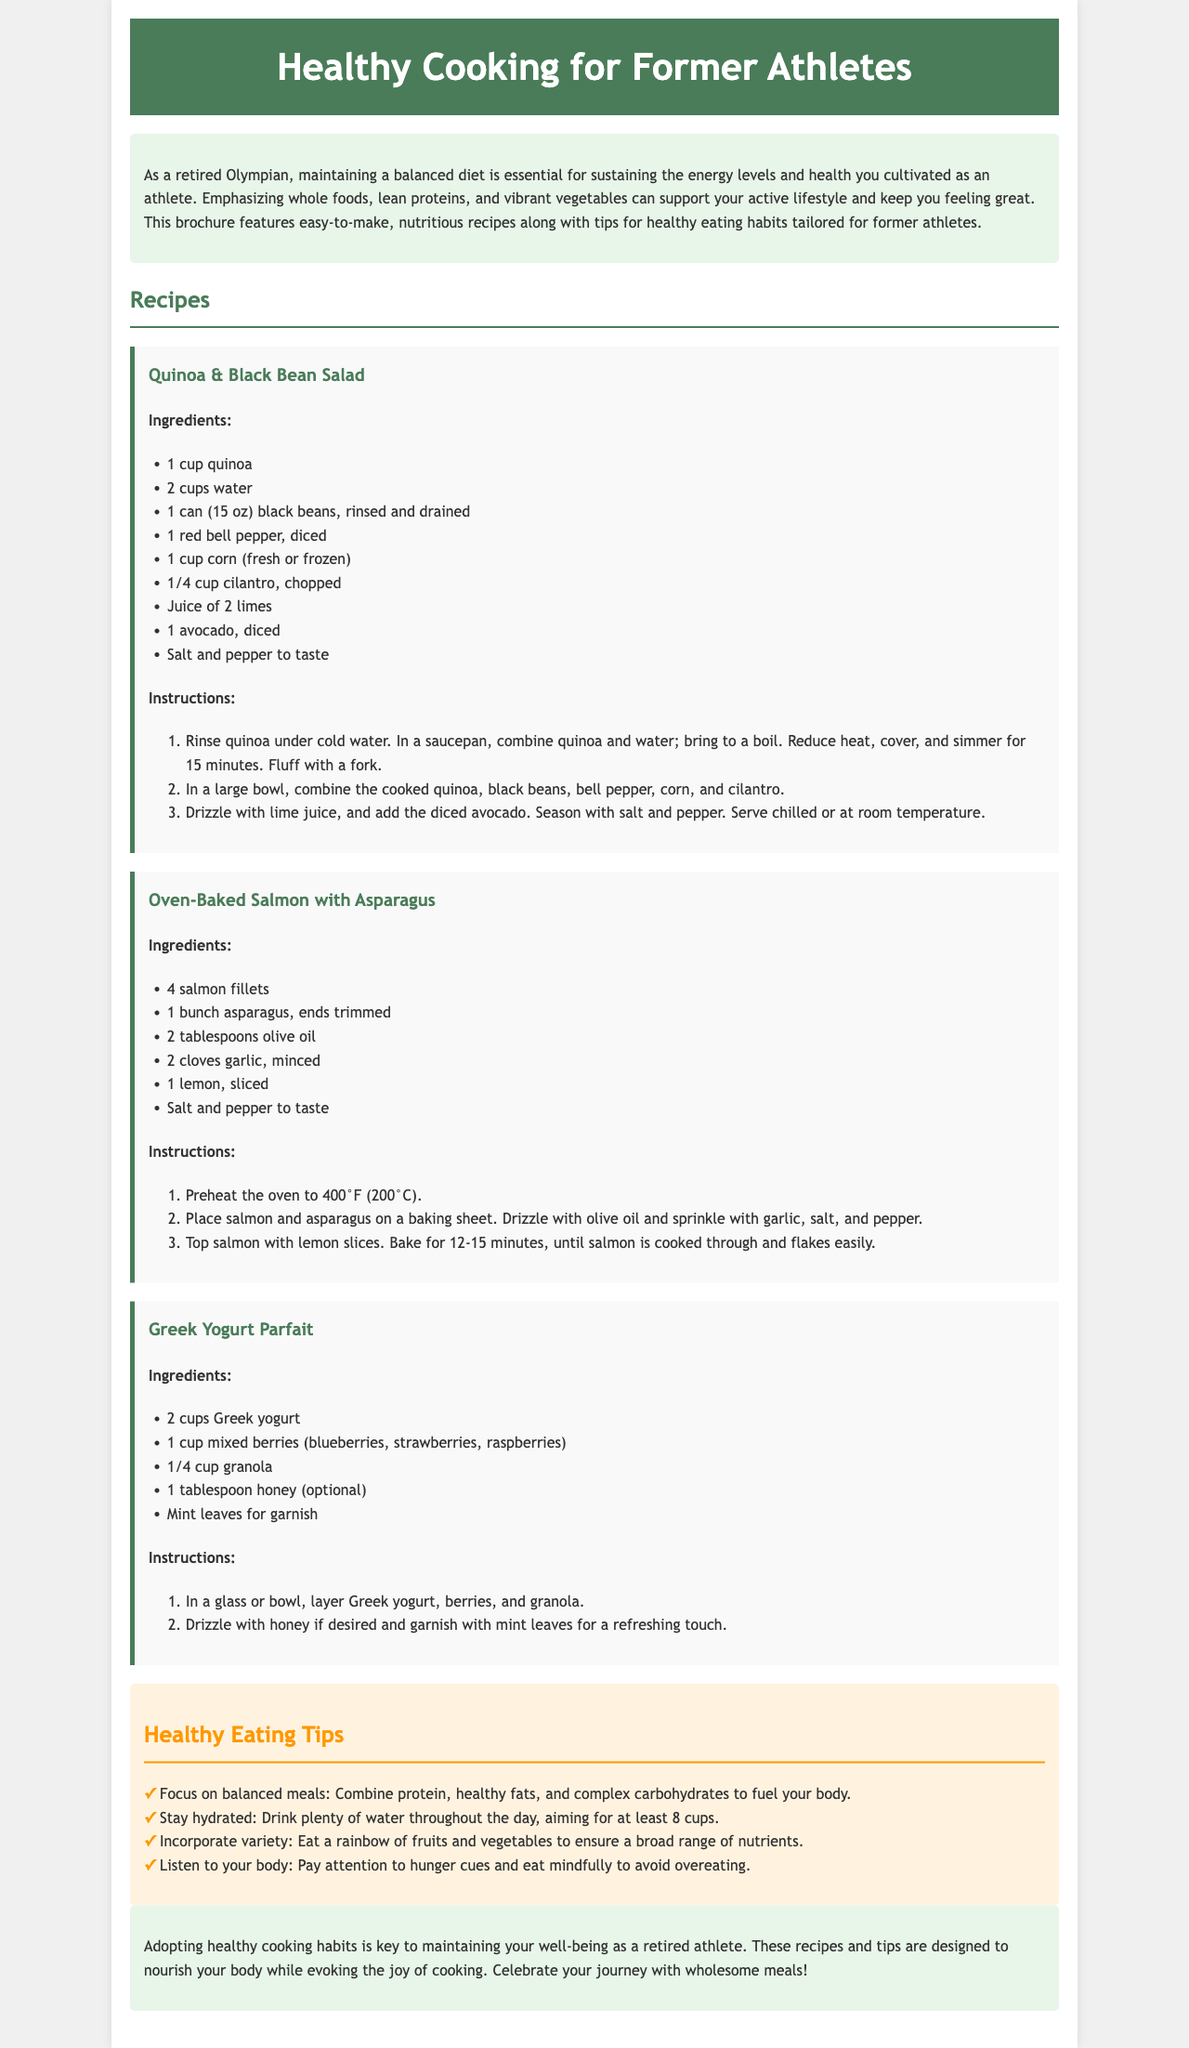what is the title of the brochure? The title of the brochure is prominently displayed in the header section.
Answer: Healthy Cooking for Former Athletes how many recipes are featured in the brochure? The recipes are listed under the "Recipes" section, with each one clearly labeled.
Answer: 3 what is the main ingredient in the "Quinoa & Black Bean Salad"? The main ingredients are listed in the ingredients section of the recipe.
Answer: Quinoa what type of fish is used in the "Oven-Baked Salmon with Asparagus"? The type of fish is specified in the title of the recipe itself.
Answer: Salmon what is included in the "Healthy Eating Tips" section? The section contains specific tips listed in bullet points for healthy eating.
Answer: Focus on balanced meals what is the cooking method for the "Oven-Baked Salmon with Asparagus"? The method is described in the instructions of the recipe.
Answer: Baked how long should the quinoa be simmered? The cooking time is detailed in the instructions of the "Quinoa & Black Bean Salad".
Answer: 15 minutes what is the recommended hydration amount mentioned in the tips? This information is specified in one of the healthy eating tips.
Answer: 8 cups how is the "Greek Yogurt Parfait" garnished? The garnish is mentioned in the instructions of the recipe.
Answer: Mint leaves 